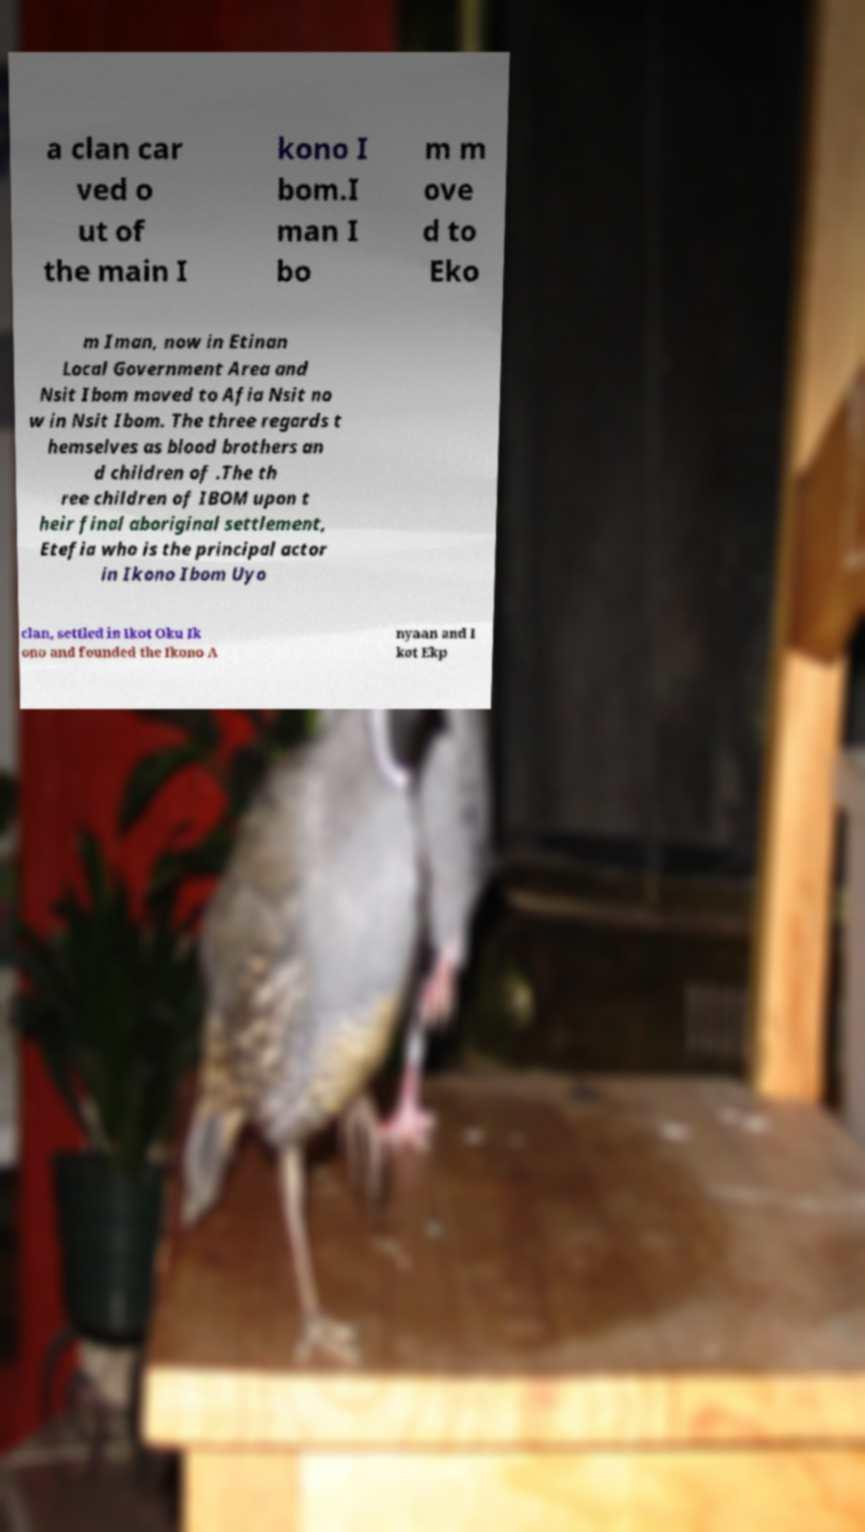Could you assist in decoding the text presented in this image and type it out clearly? a clan car ved o ut of the main I kono I bom.I man I bo m m ove d to Eko m Iman, now in Etinan Local Government Area and Nsit Ibom moved to Afia Nsit no w in Nsit Ibom. The three regards t hemselves as blood brothers an d children of .The th ree children of IBOM upon t heir final aboriginal settlement, Etefia who is the principal actor in Ikono Ibom Uyo clan, settled in Ikot Oku Ik ono and founded the Ikono A nyaan and I kot Ekp 